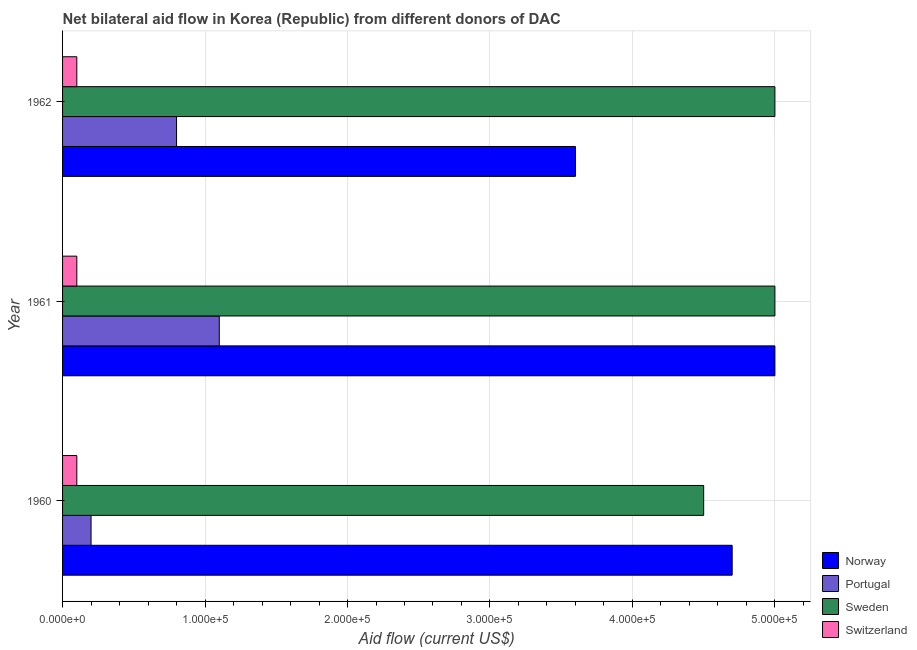How many different coloured bars are there?
Your answer should be compact. 4. How many groups of bars are there?
Make the answer very short. 3. Are the number of bars per tick equal to the number of legend labels?
Offer a very short reply. Yes. Are the number of bars on each tick of the Y-axis equal?
Offer a very short reply. Yes. How many bars are there on the 2nd tick from the top?
Keep it short and to the point. 4. What is the amount of aid given by portugal in 1962?
Offer a very short reply. 8.00e+04. Across all years, what is the maximum amount of aid given by norway?
Keep it short and to the point. 5.00e+05. Across all years, what is the minimum amount of aid given by switzerland?
Your answer should be compact. 10000. In which year was the amount of aid given by switzerland maximum?
Your answer should be compact. 1960. In which year was the amount of aid given by portugal minimum?
Keep it short and to the point. 1960. What is the total amount of aid given by portugal in the graph?
Keep it short and to the point. 2.10e+05. What is the difference between the amount of aid given by portugal in 1960 and that in 1962?
Provide a succinct answer. -6.00e+04. What is the difference between the amount of aid given by norway in 1961 and the amount of aid given by sweden in 1960?
Provide a short and direct response. 5.00e+04. In the year 1962, what is the difference between the amount of aid given by norway and amount of aid given by sweden?
Give a very brief answer. -1.40e+05. In how many years, is the amount of aid given by norway greater than 40000 US$?
Offer a very short reply. 3. What is the difference between the highest and the lowest amount of aid given by norway?
Offer a terse response. 1.40e+05. Is the sum of the amount of aid given by switzerland in 1960 and 1962 greater than the maximum amount of aid given by sweden across all years?
Your answer should be very brief. No. Is it the case that in every year, the sum of the amount of aid given by sweden and amount of aid given by norway is greater than the sum of amount of aid given by switzerland and amount of aid given by portugal?
Offer a terse response. No. What does the 1st bar from the top in 1960 represents?
Provide a short and direct response. Switzerland. What does the 2nd bar from the bottom in 1960 represents?
Your answer should be very brief. Portugal. Is it the case that in every year, the sum of the amount of aid given by norway and amount of aid given by portugal is greater than the amount of aid given by sweden?
Offer a very short reply. No. How many bars are there?
Give a very brief answer. 12. What is the difference between two consecutive major ticks on the X-axis?
Make the answer very short. 1.00e+05. Are the values on the major ticks of X-axis written in scientific E-notation?
Provide a short and direct response. Yes. Does the graph contain any zero values?
Your answer should be very brief. No. Does the graph contain grids?
Your response must be concise. Yes. How are the legend labels stacked?
Provide a succinct answer. Vertical. What is the title of the graph?
Ensure brevity in your answer.  Net bilateral aid flow in Korea (Republic) from different donors of DAC. Does "Public sector management" appear as one of the legend labels in the graph?
Offer a terse response. No. What is the label or title of the Y-axis?
Your answer should be very brief. Year. What is the Aid flow (current US$) in Norway in 1960?
Make the answer very short. 4.70e+05. What is the Aid flow (current US$) in Portugal in 1960?
Provide a succinct answer. 2.00e+04. What is the Aid flow (current US$) of Switzerland in 1960?
Keep it short and to the point. 10000. Across all years, what is the maximum Aid flow (current US$) of Switzerland?
Your answer should be compact. 10000. Across all years, what is the minimum Aid flow (current US$) of Norway?
Your answer should be compact. 3.60e+05. Across all years, what is the minimum Aid flow (current US$) of Sweden?
Give a very brief answer. 4.50e+05. Across all years, what is the minimum Aid flow (current US$) in Switzerland?
Provide a succinct answer. 10000. What is the total Aid flow (current US$) of Norway in the graph?
Offer a terse response. 1.33e+06. What is the total Aid flow (current US$) of Portugal in the graph?
Provide a short and direct response. 2.10e+05. What is the total Aid flow (current US$) in Sweden in the graph?
Keep it short and to the point. 1.45e+06. What is the difference between the Aid flow (current US$) in Switzerland in 1960 and that in 1961?
Offer a terse response. 0. What is the difference between the Aid flow (current US$) in Portugal in 1960 and that in 1962?
Keep it short and to the point. -6.00e+04. What is the difference between the Aid flow (current US$) in Sweden in 1960 and that in 1962?
Your response must be concise. -5.00e+04. What is the difference between the Aid flow (current US$) in Portugal in 1961 and that in 1962?
Offer a terse response. 3.00e+04. What is the difference between the Aid flow (current US$) of Switzerland in 1961 and that in 1962?
Your answer should be very brief. 0. What is the difference between the Aid flow (current US$) of Norway in 1960 and the Aid flow (current US$) of Portugal in 1961?
Your answer should be very brief. 3.60e+05. What is the difference between the Aid flow (current US$) in Norway in 1960 and the Aid flow (current US$) in Switzerland in 1961?
Offer a very short reply. 4.60e+05. What is the difference between the Aid flow (current US$) of Portugal in 1960 and the Aid flow (current US$) of Sweden in 1961?
Make the answer very short. -4.80e+05. What is the difference between the Aid flow (current US$) in Portugal in 1960 and the Aid flow (current US$) in Switzerland in 1961?
Provide a short and direct response. 10000. What is the difference between the Aid flow (current US$) in Sweden in 1960 and the Aid flow (current US$) in Switzerland in 1961?
Provide a short and direct response. 4.40e+05. What is the difference between the Aid flow (current US$) in Norway in 1960 and the Aid flow (current US$) in Portugal in 1962?
Offer a very short reply. 3.90e+05. What is the difference between the Aid flow (current US$) of Norway in 1960 and the Aid flow (current US$) of Sweden in 1962?
Provide a succinct answer. -3.00e+04. What is the difference between the Aid flow (current US$) of Portugal in 1960 and the Aid flow (current US$) of Sweden in 1962?
Your response must be concise. -4.80e+05. What is the difference between the Aid flow (current US$) in Sweden in 1960 and the Aid flow (current US$) in Switzerland in 1962?
Your response must be concise. 4.40e+05. What is the difference between the Aid flow (current US$) in Norway in 1961 and the Aid flow (current US$) in Portugal in 1962?
Your answer should be compact. 4.20e+05. What is the difference between the Aid flow (current US$) in Norway in 1961 and the Aid flow (current US$) in Switzerland in 1962?
Your answer should be very brief. 4.90e+05. What is the difference between the Aid flow (current US$) of Portugal in 1961 and the Aid flow (current US$) of Sweden in 1962?
Your response must be concise. -3.90e+05. What is the difference between the Aid flow (current US$) of Sweden in 1961 and the Aid flow (current US$) of Switzerland in 1962?
Ensure brevity in your answer.  4.90e+05. What is the average Aid flow (current US$) of Norway per year?
Offer a terse response. 4.43e+05. What is the average Aid flow (current US$) of Portugal per year?
Provide a short and direct response. 7.00e+04. What is the average Aid flow (current US$) in Sweden per year?
Keep it short and to the point. 4.83e+05. In the year 1960, what is the difference between the Aid flow (current US$) of Portugal and Aid flow (current US$) of Sweden?
Offer a terse response. -4.30e+05. In the year 1960, what is the difference between the Aid flow (current US$) of Portugal and Aid flow (current US$) of Switzerland?
Your answer should be compact. 10000. In the year 1960, what is the difference between the Aid flow (current US$) of Sweden and Aid flow (current US$) of Switzerland?
Make the answer very short. 4.40e+05. In the year 1961, what is the difference between the Aid flow (current US$) in Norway and Aid flow (current US$) in Portugal?
Make the answer very short. 3.90e+05. In the year 1961, what is the difference between the Aid flow (current US$) of Norway and Aid flow (current US$) of Sweden?
Ensure brevity in your answer.  0. In the year 1961, what is the difference between the Aid flow (current US$) of Norway and Aid flow (current US$) of Switzerland?
Offer a terse response. 4.90e+05. In the year 1961, what is the difference between the Aid flow (current US$) in Portugal and Aid flow (current US$) in Sweden?
Provide a succinct answer. -3.90e+05. In the year 1962, what is the difference between the Aid flow (current US$) of Norway and Aid flow (current US$) of Switzerland?
Your response must be concise. 3.50e+05. In the year 1962, what is the difference between the Aid flow (current US$) of Portugal and Aid flow (current US$) of Sweden?
Make the answer very short. -4.20e+05. In the year 1962, what is the difference between the Aid flow (current US$) of Sweden and Aid flow (current US$) of Switzerland?
Provide a short and direct response. 4.90e+05. What is the ratio of the Aid flow (current US$) of Portugal in 1960 to that in 1961?
Keep it short and to the point. 0.18. What is the ratio of the Aid flow (current US$) in Sweden in 1960 to that in 1961?
Provide a succinct answer. 0.9. What is the ratio of the Aid flow (current US$) in Norway in 1960 to that in 1962?
Your answer should be very brief. 1.31. What is the ratio of the Aid flow (current US$) of Portugal in 1960 to that in 1962?
Provide a short and direct response. 0.25. What is the ratio of the Aid flow (current US$) in Switzerland in 1960 to that in 1962?
Your answer should be compact. 1. What is the ratio of the Aid flow (current US$) in Norway in 1961 to that in 1962?
Your response must be concise. 1.39. What is the ratio of the Aid flow (current US$) of Portugal in 1961 to that in 1962?
Offer a very short reply. 1.38. What is the difference between the highest and the second highest Aid flow (current US$) of Norway?
Offer a terse response. 3.00e+04. What is the difference between the highest and the lowest Aid flow (current US$) of Norway?
Offer a terse response. 1.40e+05. What is the difference between the highest and the lowest Aid flow (current US$) of Portugal?
Your answer should be compact. 9.00e+04. What is the difference between the highest and the lowest Aid flow (current US$) in Switzerland?
Your answer should be compact. 0. 